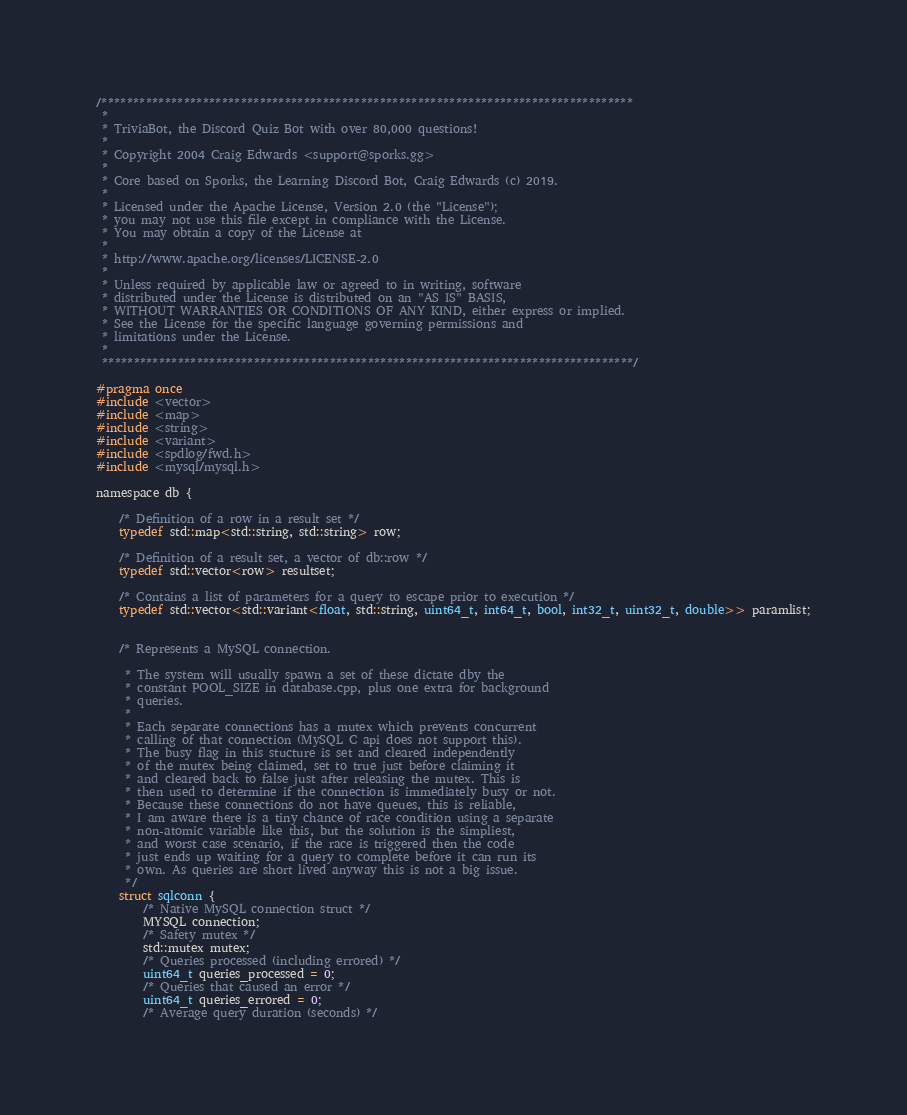<code> <loc_0><loc_0><loc_500><loc_500><_C_>/************************************************************************************
 * 
 * TriviaBot, the Discord Quiz Bot with over 80,000 questions!
 *
 * Copyright 2004 Craig Edwards <support@sporks.gg>
 *
 * Core based on Sporks, the Learning Discord Bot, Craig Edwards (c) 2019.
 *
 * Licensed under the Apache License, Version 2.0 (the "License");
 * you may not use this file except in compliance with the License.
 * You may obtain a copy of the License at
 *
 * http://www.apache.org/licenses/LICENSE-2.0
 *
 * Unless required by applicable law or agreed to in writing, software
 * distributed under the License is distributed on an "AS IS" BASIS,
 * WITHOUT WARRANTIES OR CONDITIONS OF ANY KIND, either express or implied.
 * See the License for the specific language governing permissions and
 * limitations under the License.
 *
 ************************************************************************************/

#pragma once
#include <vector>
#include <map>
#include <string>
#include <variant>
#include <spdlog/fwd.h>
#include <mysql/mysql.h>

namespace db {

	/* Definition of a row in a result set */
	typedef std::map<std::string, std::string> row;

	/* Definition of a result set, a vector of db::row */
	typedef std::vector<row> resultset;

	/* Contains a list of parameters for a query to escape prior to execution */
	typedef std::vector<std::variant<float, std::string, uint64_t, int64_t, bool, int32_t, uint32_t, double>> paramlist;


	/* Represents a MySQL connection.

	 * The system will usually spawn a set of these dictate dby the
	 * constant POOL_SIZE in database.cpp, plus one extra for background
	 * queries.
	 * 
	 * Each separate connections has a mutex which prevents concurrent
	 * calling of that connection (MySQL C api does not support this).
	 * The busy flag in this stucture is set and cleared independently
	 * of the mutex being claimed, set to true just before claiming it
	 * and cleared back to false just after releasing the mutex. This is
	 * then used to determine if the connection is immediately busy or not.
	 * Because these connections do not have queues, this is reliable,
	 * I am aware there is a tiny chance of race condition using a separate
	 * non-atomic variable like this, but the solution is the simpliest,
	 * and worst case scenario, if the race is triggered then the code
	 * just ends up waiting for a query to complete before it can run its
	 * own. As queries are short lived anyway this is not a big issue.
	 */
	struct sqlconn {
		/* Native MySQL connection struct */
		MYSQL connection;
		/* Safety mutex */
		std::mutex mutex;
		/* Queries processed (including errored) */
		uint64_t queries_processed = 0;
		/* Queries that caused an error */
		uint64_t queries_errored = 0;
		/* Average query duration (seconds) */</code> 